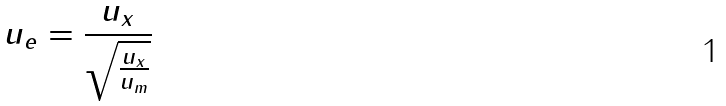<formula> <loc_0><loc_0><loc_500><loc_500>u _ { e } = \frac { u _ { x } } { \sqrt { \frac { u _ { x } } { u _ { m } } } }</formula> 